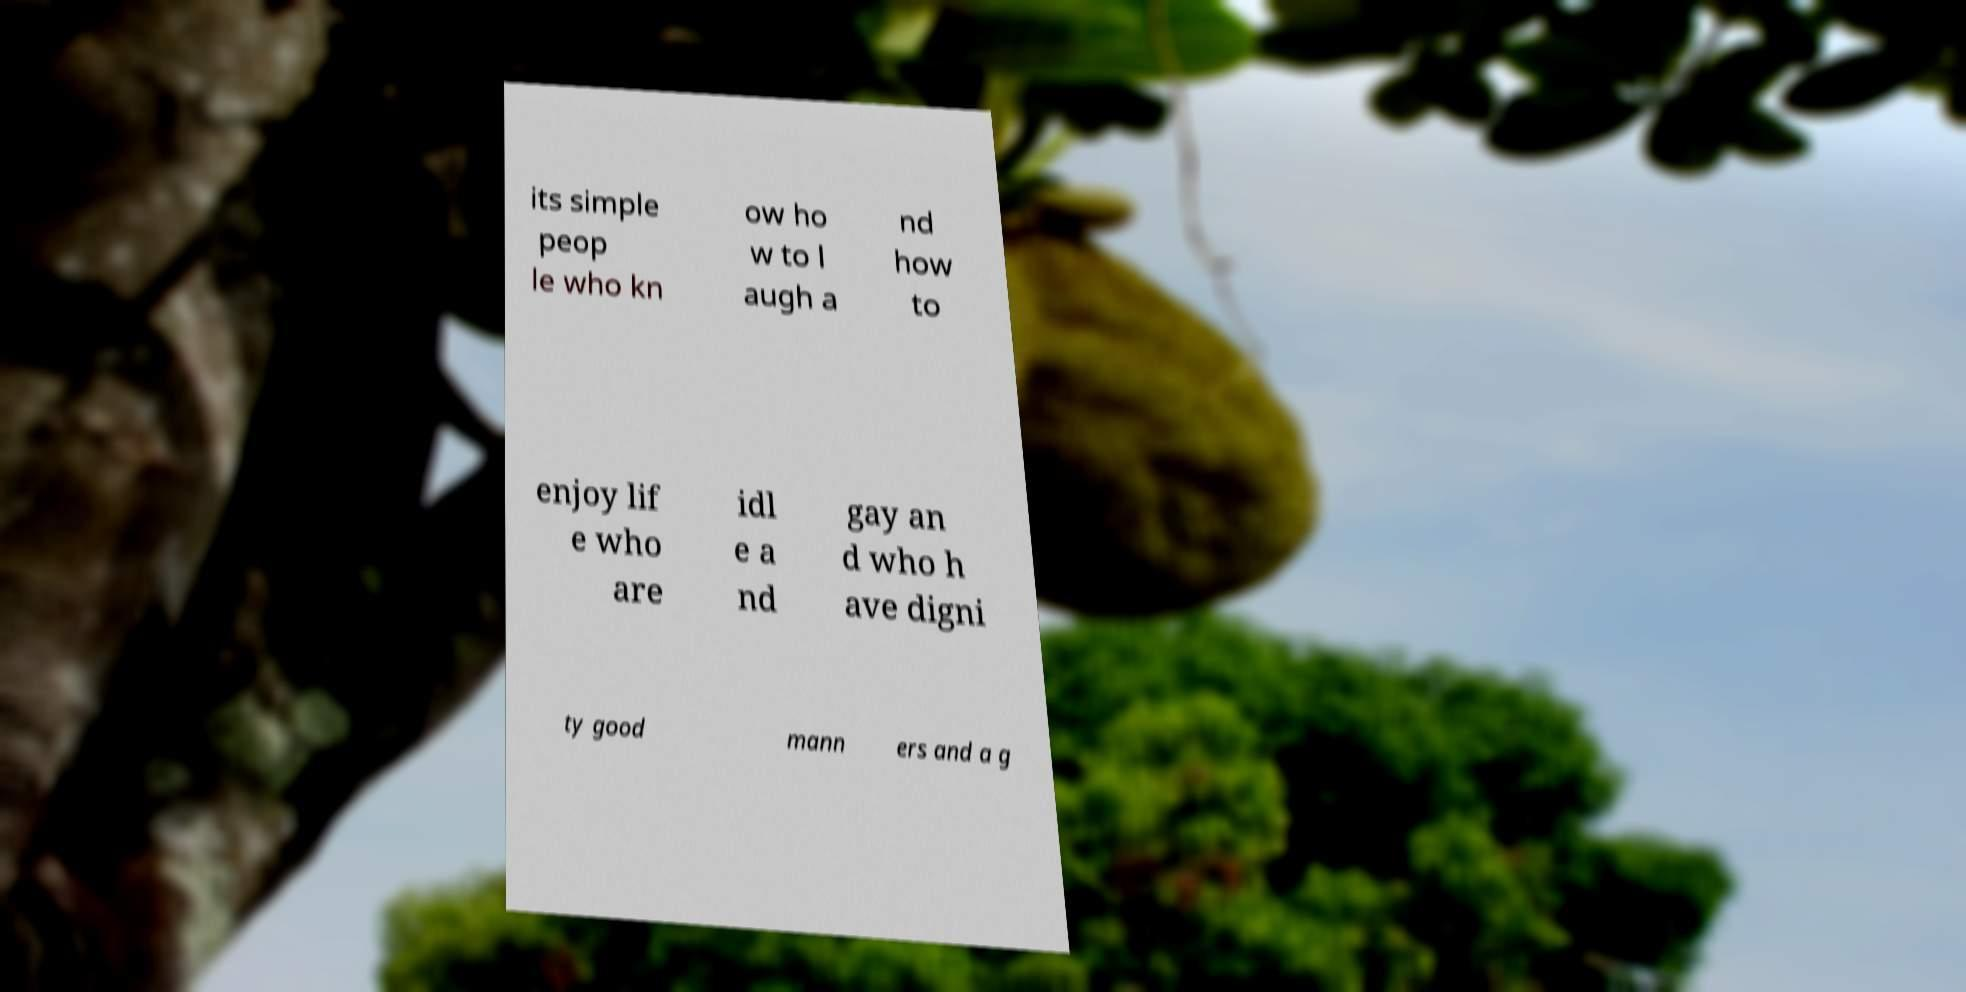Can you read and provide the text displayed in the image?This photo seems to have some interesting text. Can you extract and type it out for me? its simple peop le who kn ow ho w to l augh a nd how to enjoy lif e who are idl e a nd gay an d who h ave digni ty good mann ers and a g 